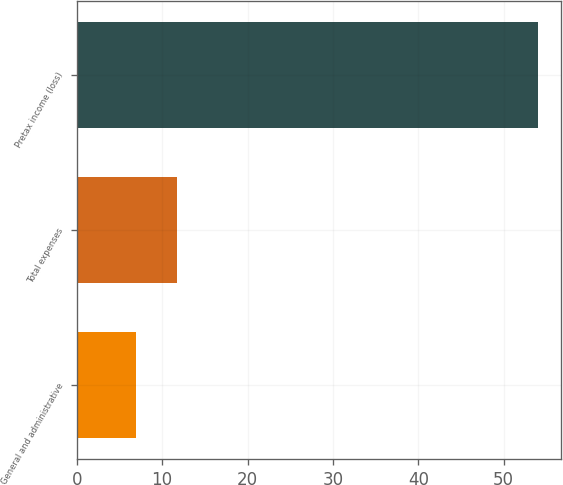Convert chart to OTSL. <chart><loc_0><loc_0><loc_500><loc_500><bar_chart><fcel>General and administrative<fcel>Total expenses<fcel>Pretax income (loss)<nl><fcel>7<fcel>11.7<fcel>54<nl></chart> 